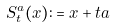Convert formula to latex. <formula><loc_0><loc_0><loc_500><loc_500>\text { } S _ { t } ^ { a } ( x ) \colon = x + t a</formula> 